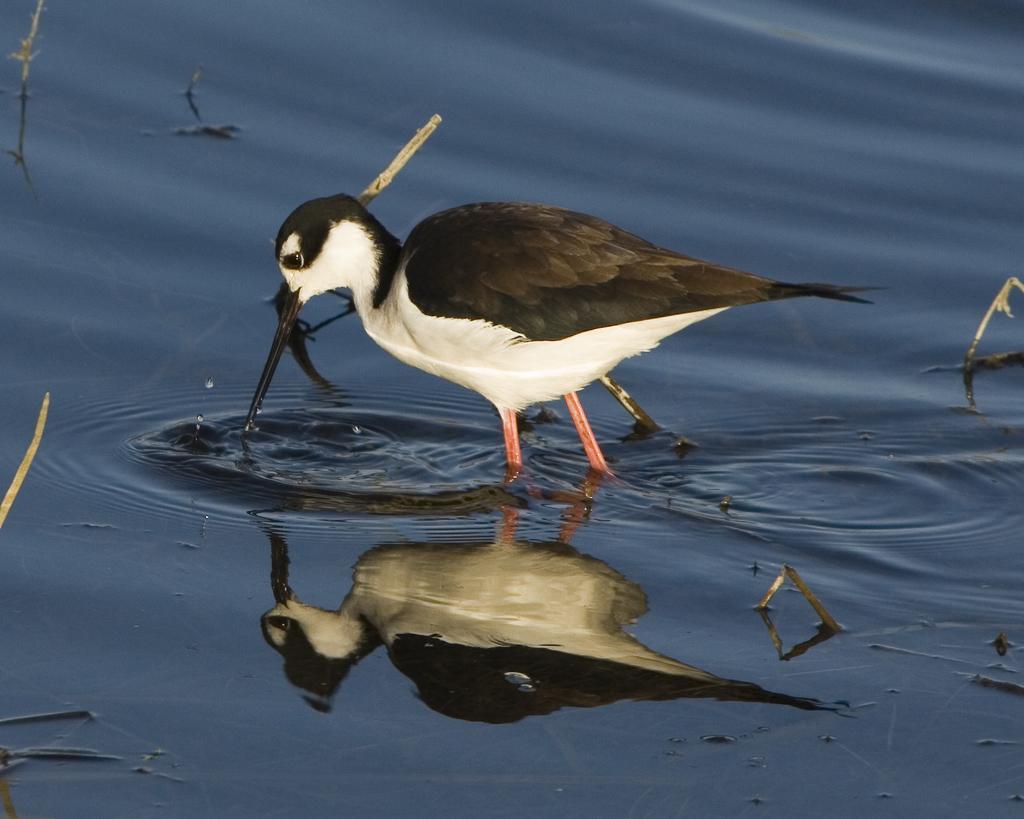In one or two sentences, can you explain what this image depicts? In this image, we can see a bird is standing in the water. Here we can see few objects. 